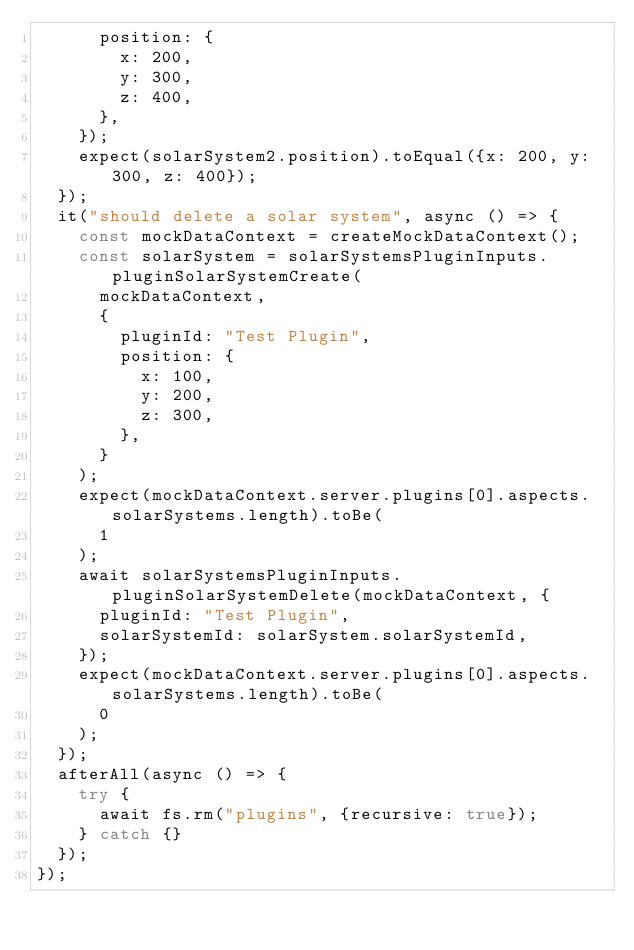Convert code to text. <code><loc_0><loc_0><loc_500><loc_500><_TypeScript_>      position: {
        x: 200,
        y: 300,
        z: 400,
      },
    });
    expect(solarSystem2.position).toEqual({x: 200, y: 300, z: 400});
  });
  it("should delete a solar system", async () => {
    const mockDataContext = createMockDataContext();
    const solarSystem = solarSystemsPluginInputs.pluginSolarSystemCreate(
      mockDataContext,
      {
        pluginId: "Test Plugin",
        position: {
          x: 100,
          y: 200,
          z: 300,
        },
      }
    );
    expect(mockDataContext.server.plugins[0].aspects.solarSystems.length).toBe(
      1
    );
    await solarSystemsPluginInputs.pluginSolarSystemDelete(mockDataContext, {
      pluginId: "Test Plugin",
      solarSystemId: solarSystem.solarSystemId,
    });
    expect(mockDataContext.server.plugins[0].aspects.solarSystems.length).toBe(
      0
    );
  });
  afterAll(async () => {
    try {
      await fs.rm("plugins", {recursive: true});
    } catch {}
  });
});
</code> 